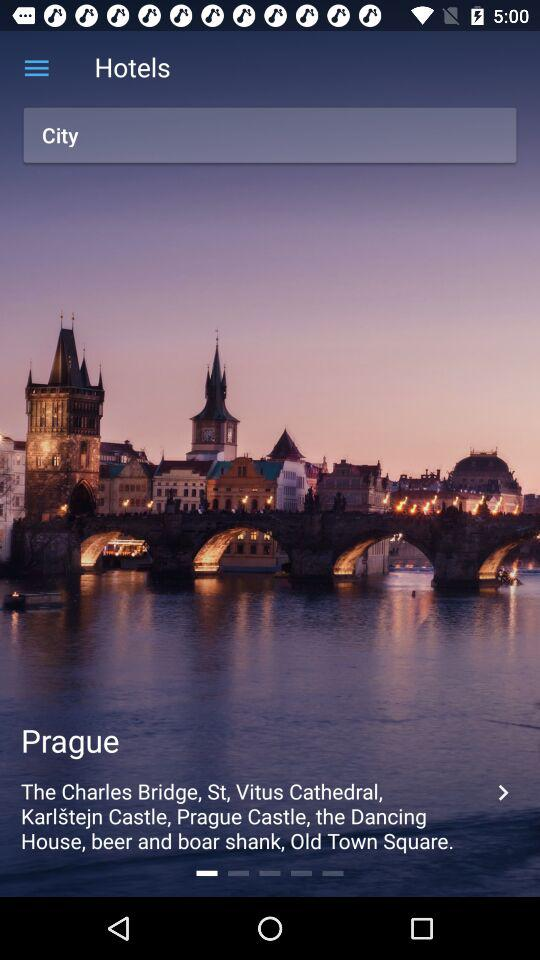What is the mentioned location? The mentioned location is Prague. 